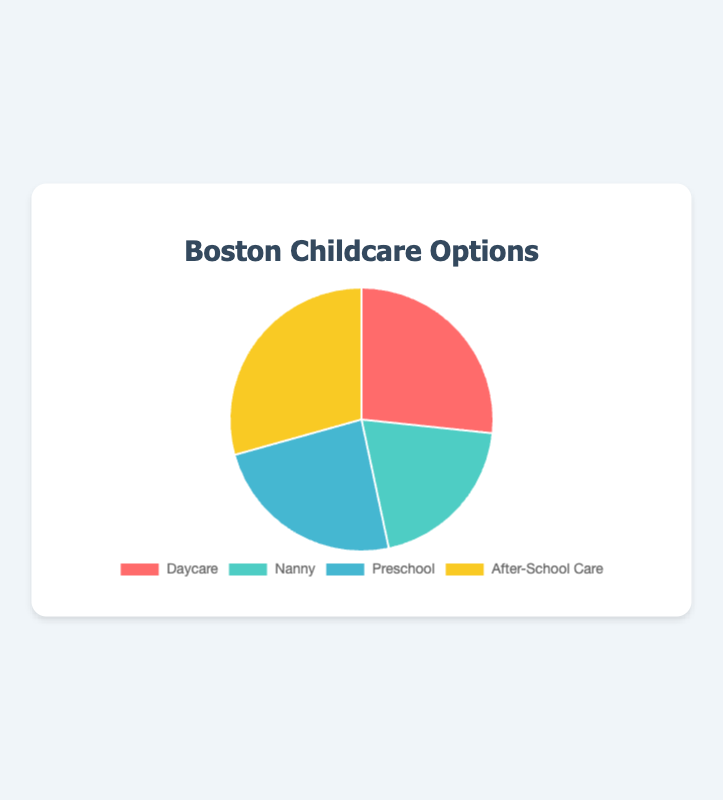What is the childcare option with the highest capacity? The childcare option with the highest capacity can be determined by looking at the largest slice in the pie chart. The label of this slice will indicate the type.
Answer: After-School Care Which type of childcare option constitutes the smallest portion of the pie chart? The smallest portion corresponds to the smallest slice in the pie chart. By looking at the labels, we can identify this type.
Answer: Nanny What is the total capacity for all childcare options combined? To find the total capacity, sum the capacities of all childcare types: 200 (Daycare) + 150 (Nanny) + 180 (Preschool) + 220 (After-School Care).
Answer: 750 How does the capacity of Nanny services compare to Daycare services? By comparing the Nanny slice to the Daycare slice, it's clear that the Nanny slice is smaller. We can confirm by looking at the capacities: Daycare has 200, and Nanny has 150.
Answer: Nanny has a lower capacity than Daycare What percentage of the childcare capacity is provided by After-School Care? To find the percentage, divide After-School Care's capacity by the total capacity and multiply by 100: (220 / 750) * 100.
Answer: 29.33% Which childcare option has a higher capacity: Preschool or Daycare? By comparing the proportions of the slices or referring to the capacities directly, we see that Daycare has 200, while Preschool has 180.
Answer: Daycare If you combine the capacities of Daycare and Preschool, what fraction of the total capacity does this represent? Combine their capacities: 200 (Daycare) + 180 (Preschool) = 380; then divide by the total: 380 / 750.
Answer: 0.507 or 50.7% What is the difference in capacity between the highest and lowest capacity childcare options? Subtract the capacity of the lowest (Nanny: 150) from the highest (After-School Care: 220).
Answer: 70 If one slice is red and another slice is yellow, which childcare types might they represent? According to the predefined color scheme, Daycare is red and After-School Care is yellow.
Answer: Daycare and After-School Care Compare the sum of capacities of Nanny and Preschool to the capacity of After-School Care. Calculate the sum of Nanny and Preschool: 150 + 180 = 330. Compare this with After-School Care's capacity: 220.
Answer: Nanny and Preschool combined have a higher capacity than After-School Care 